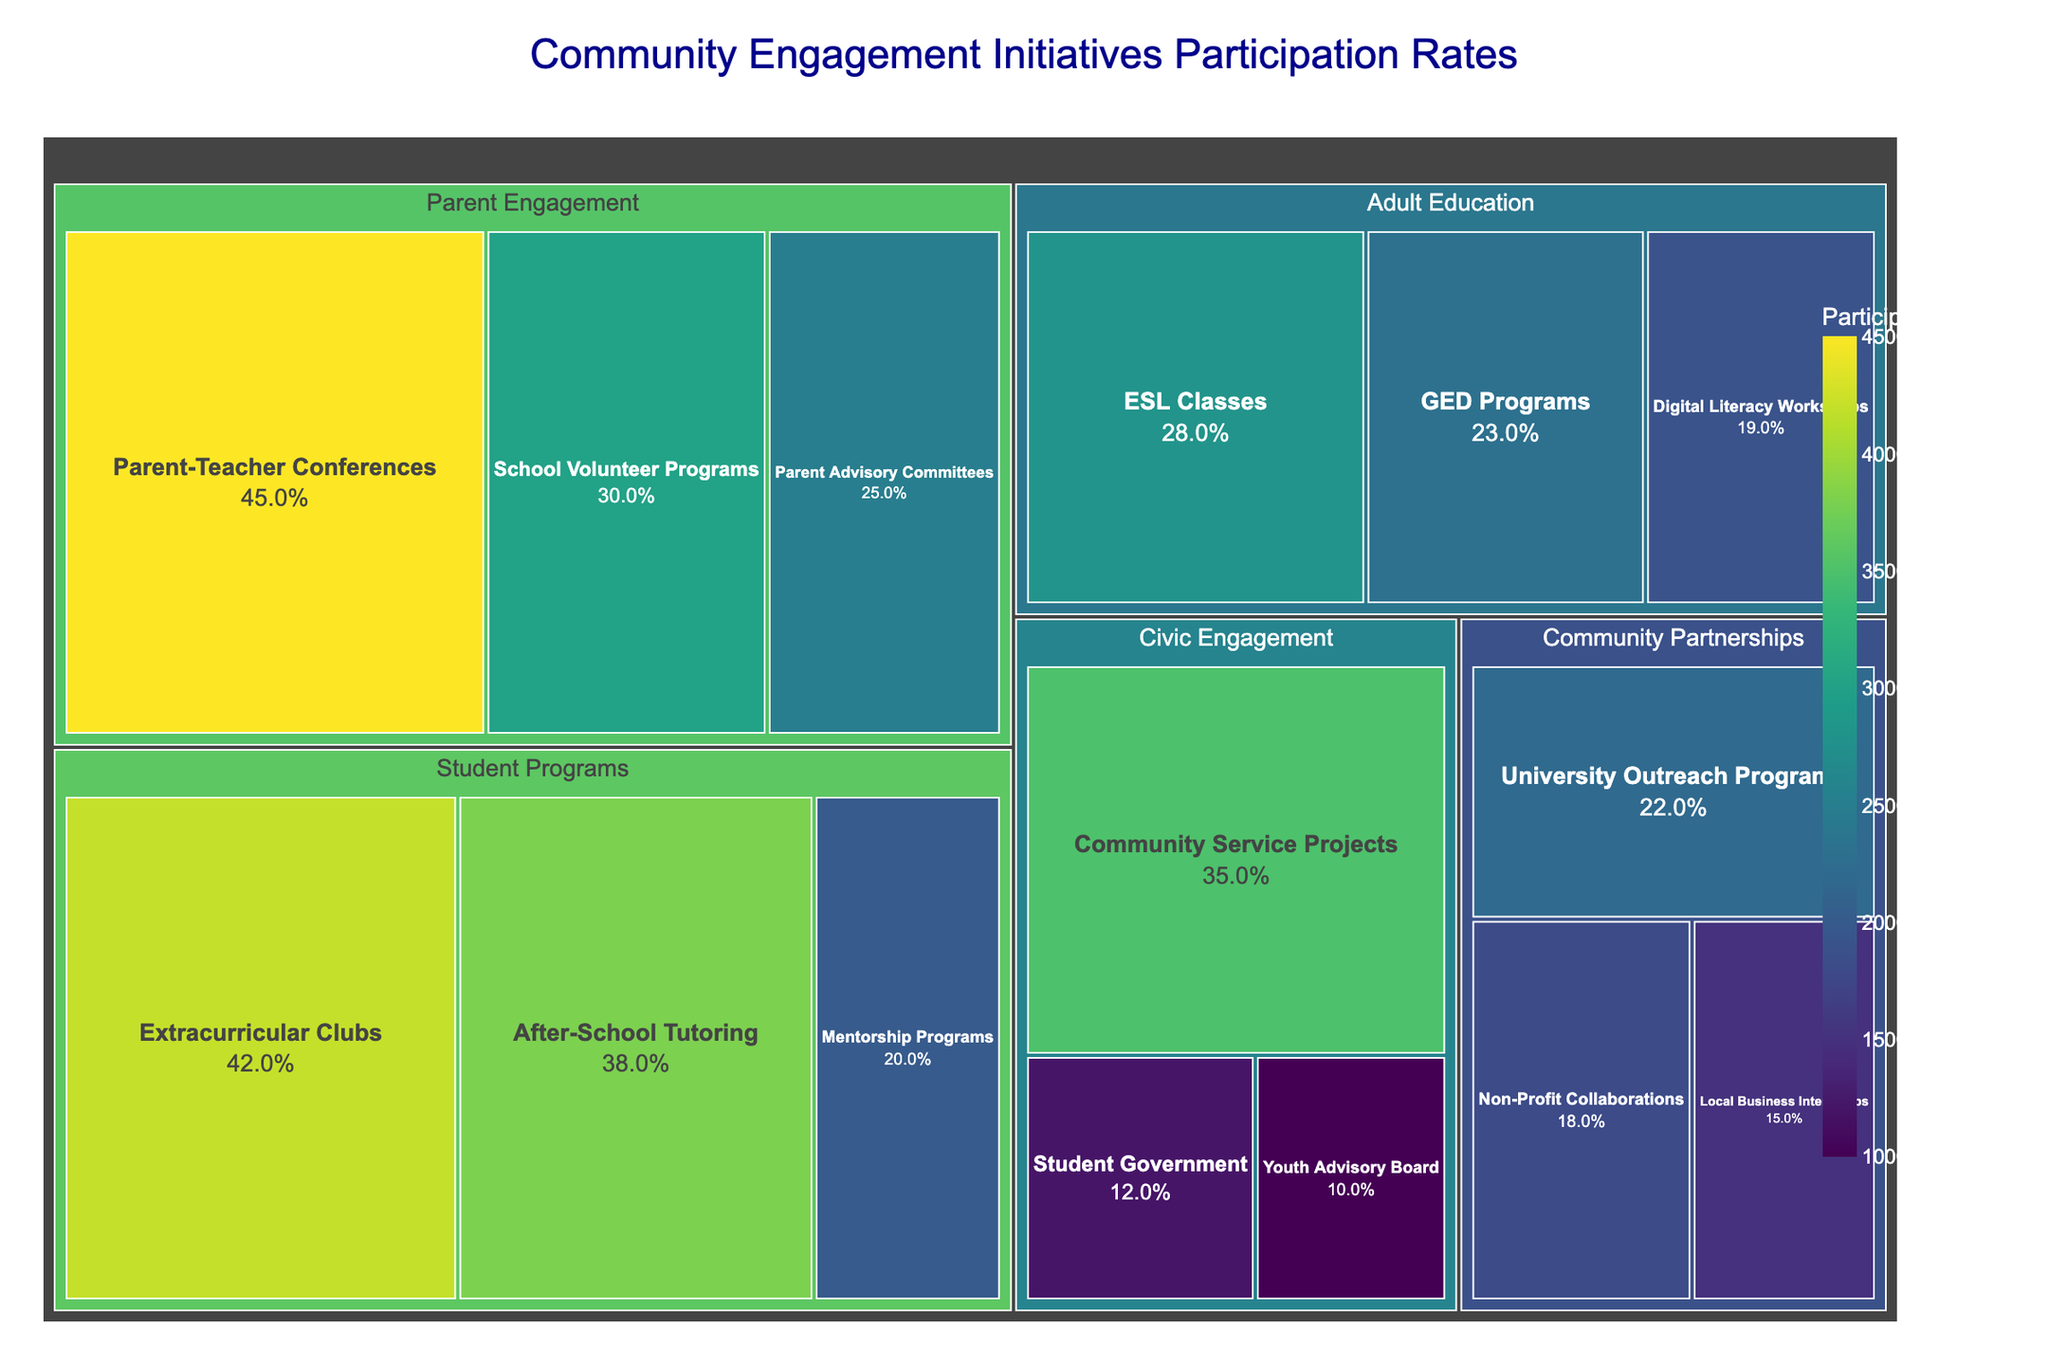What is the title of the treemap? The title is the text displayed at the top of the treemap figure indicating the main topic
Answer: Community Engagement Initiatives Participation Rates Which subcategory has the highest participation rate? Look for the subcategory with the largest segment and highest value on the treemap
Answer: Parent-Teacher Conferences What is the participation rate for Extracurricular Clubs? Find the segment labeled "Extracurricular Clubs" and note the numerical participation rate
Answer: 42% What is the combined participation rate for all subcategories under Community Partnerships? Identify all subcategories under "Community Partnerships" and add their participation rates: 15% (Local Business Internships) + 22% (University Outreach Programs) + 18% (Non-Profit Collaborations)
Answer: 55% Which category has the most subcategories? Count the number of subcategories listed under each category
Answer: Student Programs How does the participation rate for After-School Tutoring compare to GED Programs? Find the participation rates for both subcategories and compare them: After-School Tutoring (38%) vs. GED Programs (23%)
Answer: After-School Tutoring has a higher participation rate Which subcategories have participation rates below 20%? Find and list all subcategories with participation rates less than 20%: Mentorship Programs (20%), Local Business Internships (15%), Non-Profit Collaborations (18%), Digital Literacy Workshops (19%), Student Government (12%), Youth Advisory Board (10%)
Answer: Local Business Internships, Non-Profit Collaborations, Digital Literacy Workshops, Student Government, Youth Advisory Board What's the average participation rate for subcategories under Civic Engagement? Average the participation rates for subcategories under "Civic Engagement": (12% + 35% + 10%) / 3 = 57% / 3
Answer: 19% Which category has the lowest overall participation rate if you sum the participation rates of its subcategories? Sum the participation rates for each category and compare: Parent Engagement (100%), Student Programs (100%), Community Partnerships (55%), Adult Education (70%), Civic Engagement (57%)
Answer: Civic Engagement How many subcategories have participation rates between 20% and 30%? Count all segments with participation rates that are within the range of 20% to 30%: Parent Advisory Committees (25%), ESL Classes (28%), GED Programs (23%), University Outreach Programs (22%)
Answer: 4 